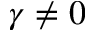<formula> <loc_0><loc_0><loc_500><loc_500>\gamma \neq 0</formula> 